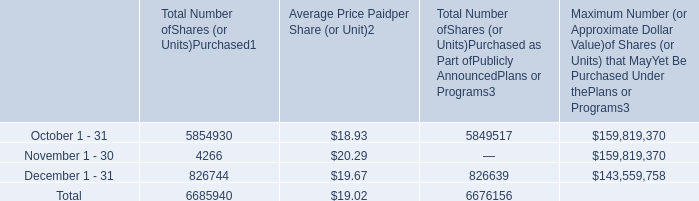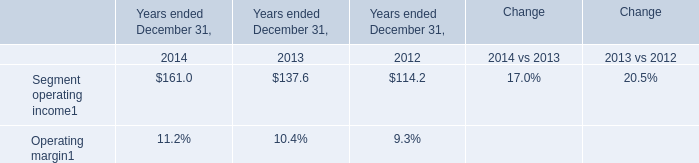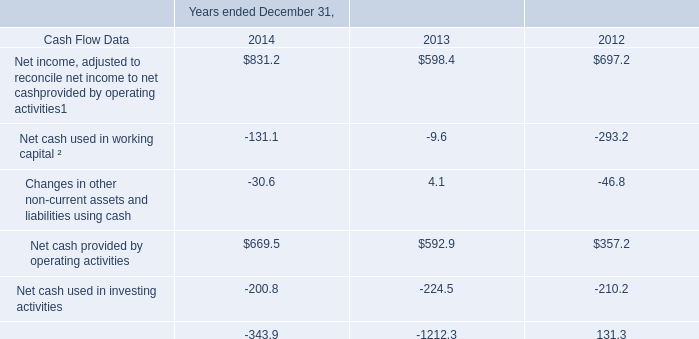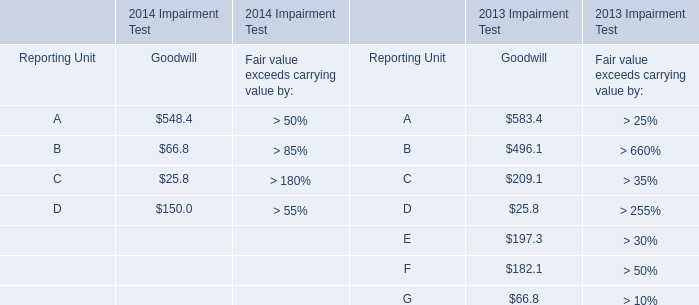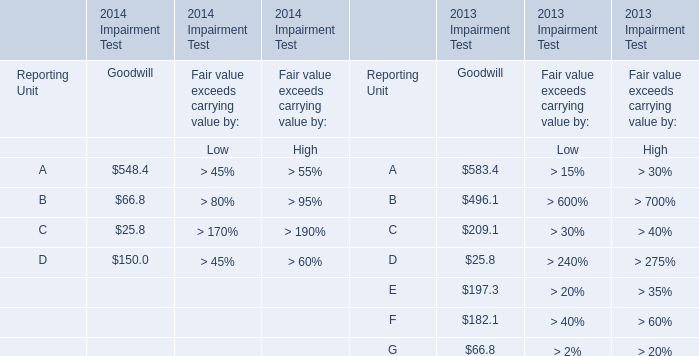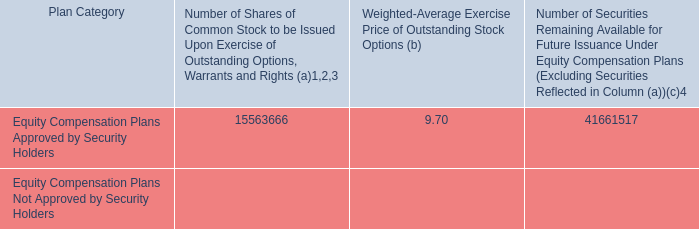what was the total amount of share repurchase authorized in 2015 and 2014 by the board in milions 
Computations: (300.0 + 300.0)
Answer: 600.0. 